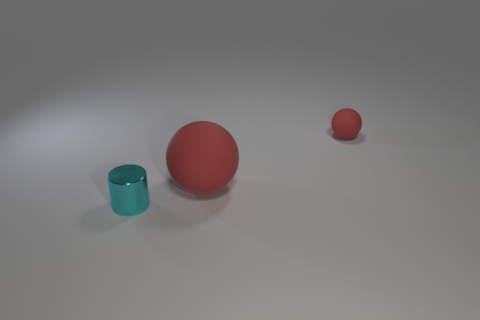What are the colors and materials of the objects presented in the image? The objects include a small blue matte cup, a large red matte ball, and a tiny red matte ball. 